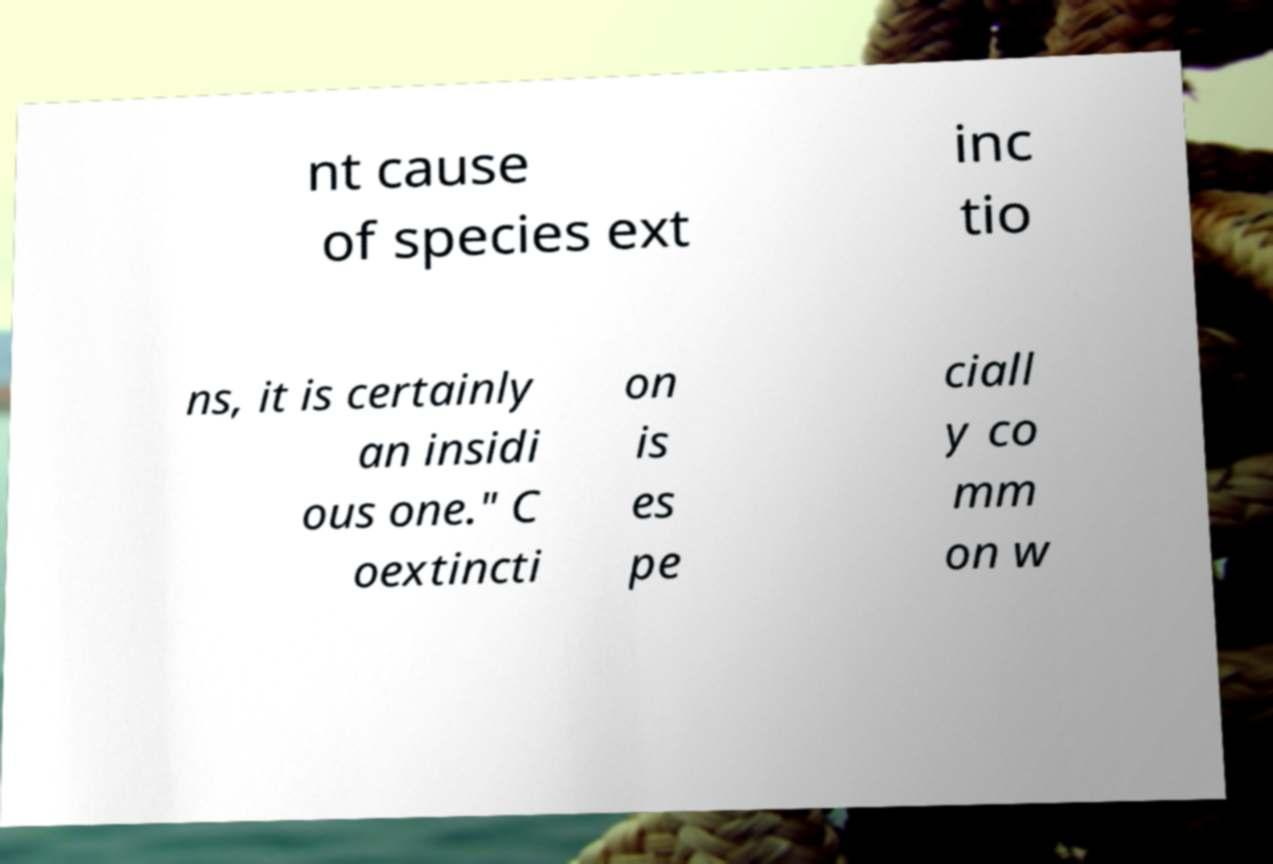Could you extract and type out the text from this image? nt cause of species ext inc tio ns, it is certainly an insidi ous one." C oextincti on is es pe ciall y co mm on w 